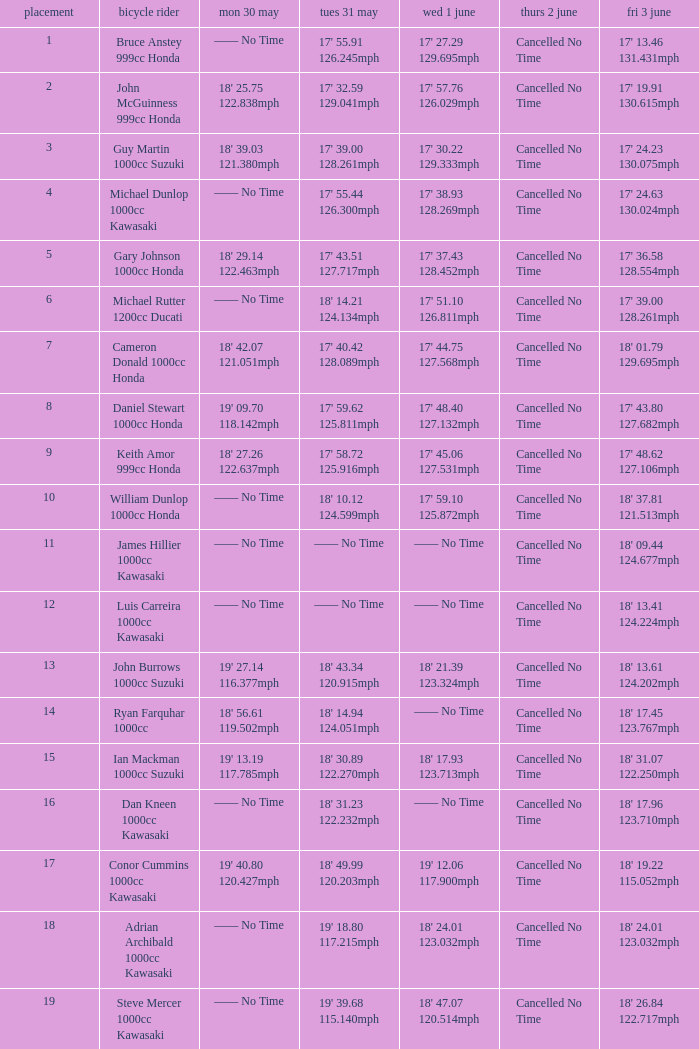What is the Mon 30 May time for the rider whose Fri 3 June time was 17' 13.46 131.431mph? —— No Time. 